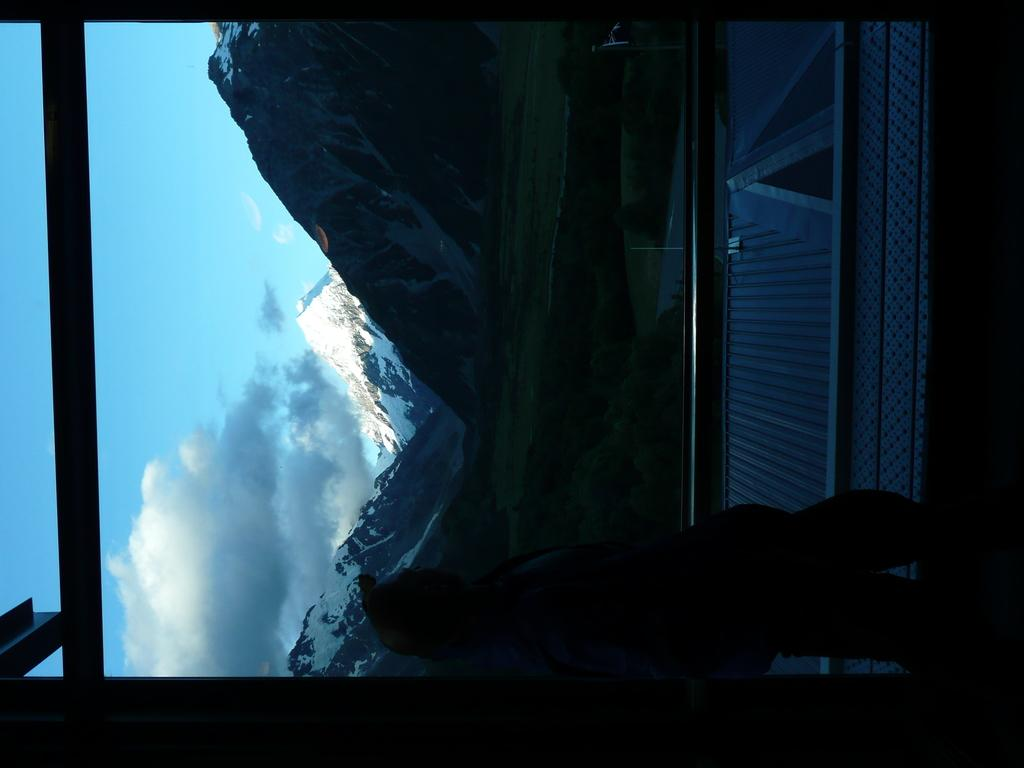What is the main subject of the image? There is a person standing in the image. What can be seen in the background of the image? There are mountains in the background of the image. What is the condition of the mountains? The mountains are covered with snow. What is visible above the mountains? The sky is visible in the image. How would you describe the sky in the image? The sky is a bit cloudy. What type of bulb is being used to light up the mountains in the image? There is no bulb present in the image, as the mountains are naturally illuminated by sunlight. Can you tell me how many clubs are visible in the image? There are no clubs present in the image. 